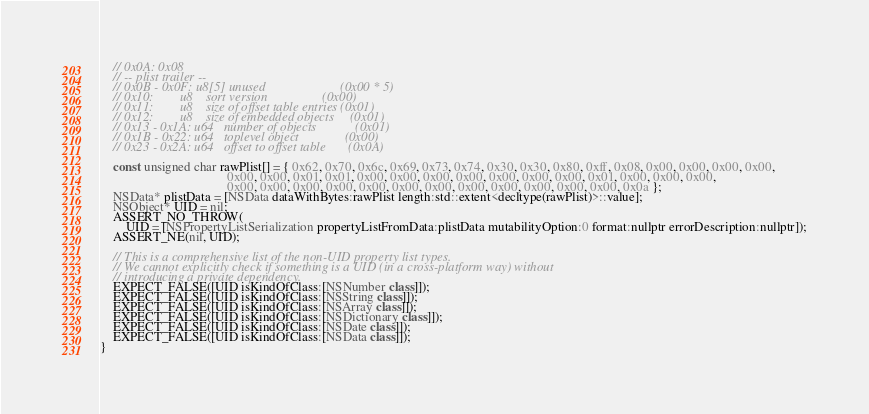Convert code to text. <code><loc_0><loc_0><loc_500><loc_500><_ObjectiveC_>    // 0x0A: 0x08
    // -- plist trailer --
    // 0x0B - 0x0F: u8[5] unused                       (0x00 * 5)
    // 0x10:        u8    sort version                 (0x00)
    // 0x11:        u8    size of offset table entries (0x01)
    // 0x12:        u8    size of embedded objects     (0x01)
    // 0x13 - 0x1A: u64   number of objects            (0x01)
    // 0x1B - 0x22: u64   toplevel object              (0x00)
    // 0x23 - 0x2A: u64   offset to offset table       (0x0A)

    const unsigned char rawPlist[] = { 0x62, 0x70, 0x6c, 0x69, 0x73, 0x74, 0x30, 0x30, 0x80, 0xff, 0x08, 0x00, 0x00, 0x00, 0x00,
                                       0x00, 0x00, 0x01, 0x01, 0x00, 0x00, 0x00, 0x00, 0x00, 0x00, 0x00, 0x01, 0x00, 0x00, 0x00,
                                       0x00, 0x00, 0x00, 0x00, 0x00, 0x00, 0x00, 0x00, 0x00, 0x00, 0x00, 0x00, 0x0a };
    NSData* plistData = [NSData dataWithBytes:rawPlist length:std::extent<decltype(rawPlist)>::value];
    NSObject* UID = nil;
    ASSERT_NO_THROW(
        UID = [NSPropertyListSerialization propertyListFromData:plistData mutabilityOption:0 format:nullptr errorDescription:nullptr]);
    ASSERT_NE(nil, UID);

    // This is a comprehensive list of the non-UID property list types.
    // We cannot explicitly check if something is a UID (in a cross-platform way) without
    // introducing a private dependency.
    EXPECT_FALSE([UID isKindOfClass:[NSNumber class]]);
    EXPECT_FALSE([UID isKindOfClass:[NSString class]]);
    EXPECT_FALSE([UID isKindOfClass:[NSArray class]]);
    EXPECT_FALSE([UID isKindOfClass:[NSDictionary class]]);
    EXPECT_FALSE([UID isKindOfClass:[NSDate class]]);
    EXPECT_FALSE([UID isKindOfClass:[NSData class]]);
}
</code> 